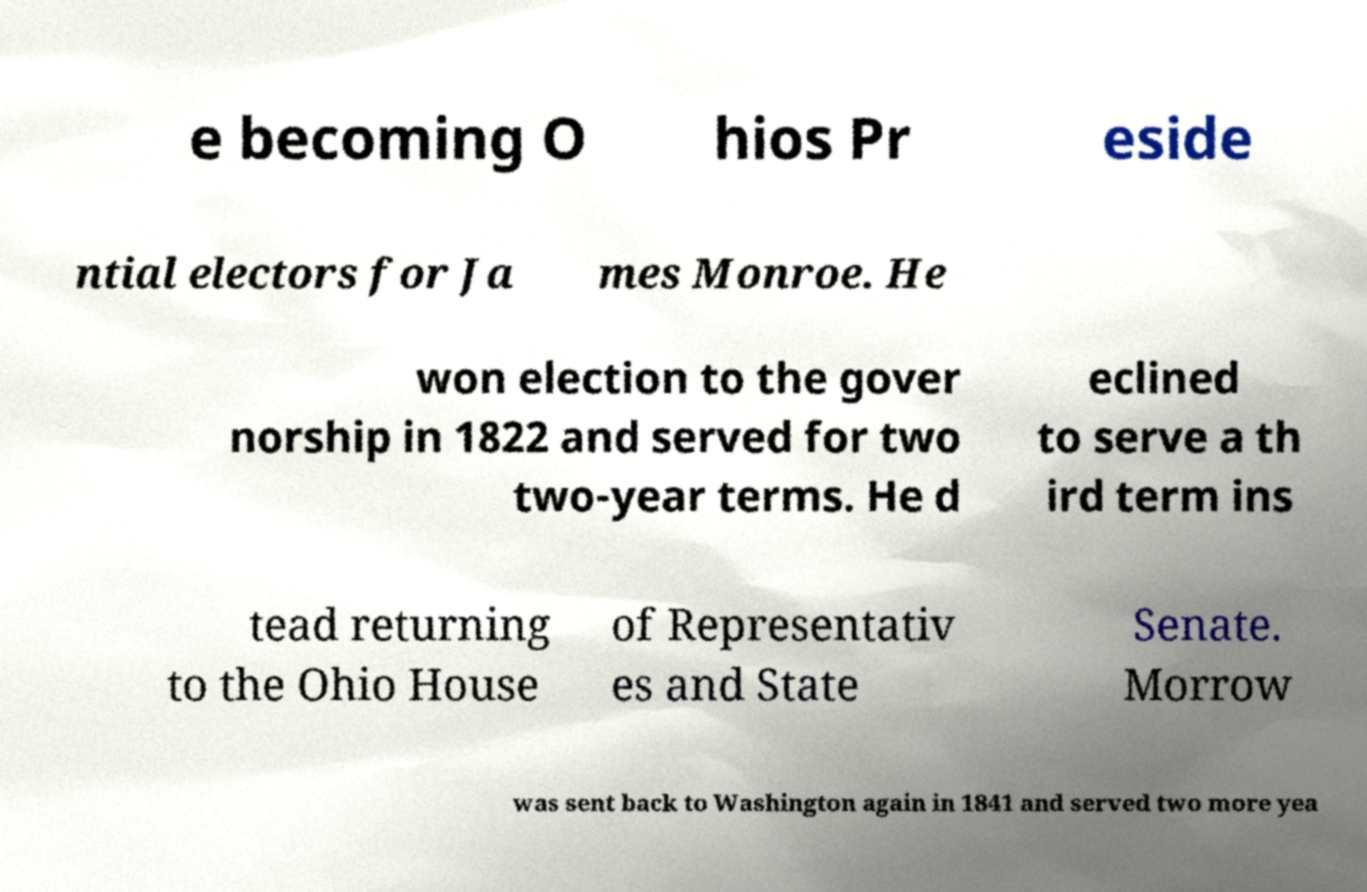Please identify and transcribe the text found in this image. e becoming O hios Pr eside ntial electors for Ja mes Monroe. He won election to the gover norship in 1822 and served for two two-year terms. He d eclined to serve a th ird term ins tead returning to the Ohio House of Representativ es and State Senate. Morrow was sent back to Washington again in 1841 and served two more yea 